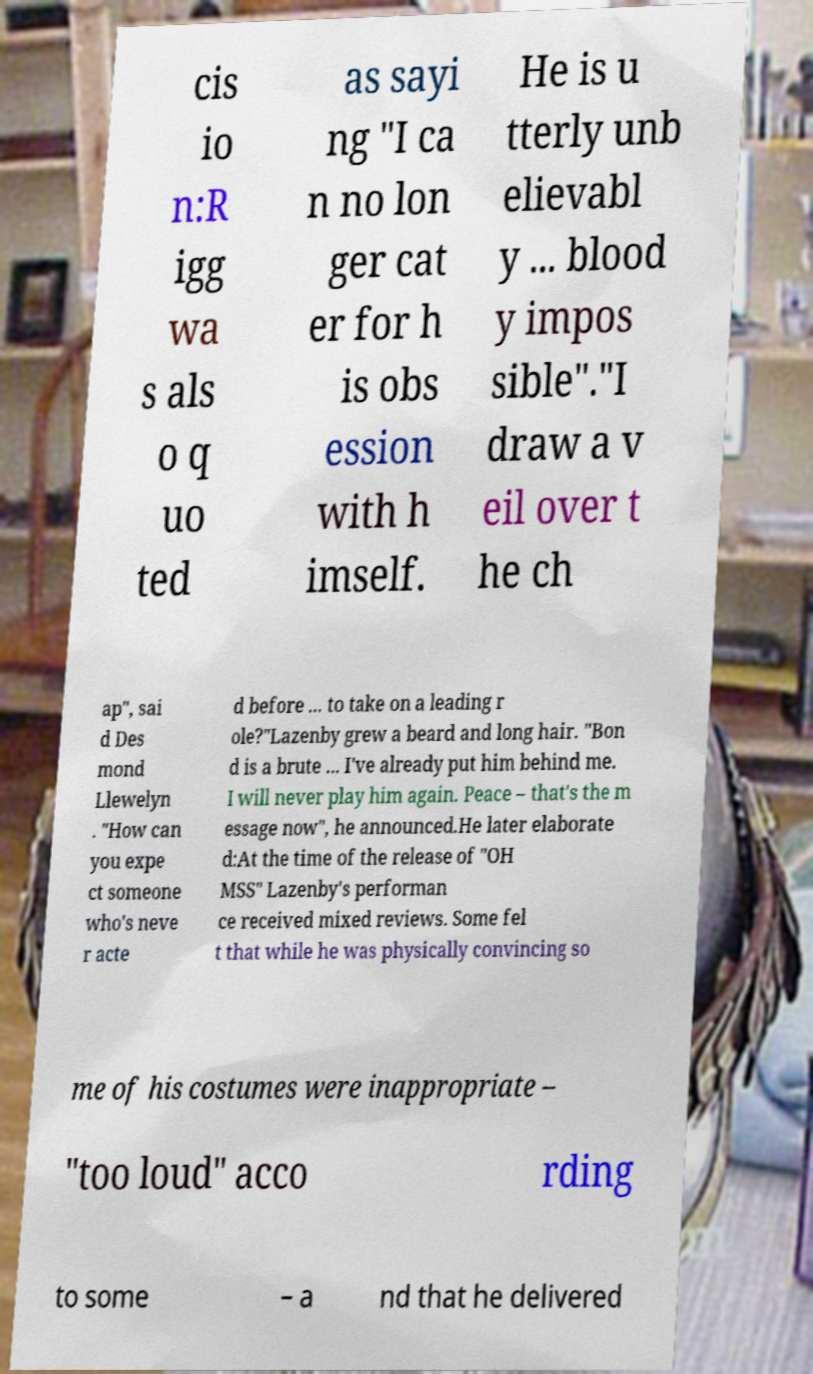Can you accurately transcribe the text from the provided image for me? cis io n:R igg wa s als o q uo ted as sayi ng "I ca n no lon ger cat er for h is obs ession with h imself. He is u tterly unb elievabl y ... blood y impos sible"."I draw a v eil over t he ch ap", sai d Des mond Llewelyn . "How can you expe ct someone who's neve r acte d before ... to take on a leading r ole?"Lazenby grew a beard and long hair. "Bon d is a brute ... I've already put him behind me. I will never play him again. Peace – that's the m essage now", he announced.He later elaborate d:At the time of the release of "OH MSS" Lazenby's performan ce received mixed reviews. Some fel t that while he was physically convincing so me of his costumes were inappropriate – "too loud" acco rding to some – a nd that he delivered 